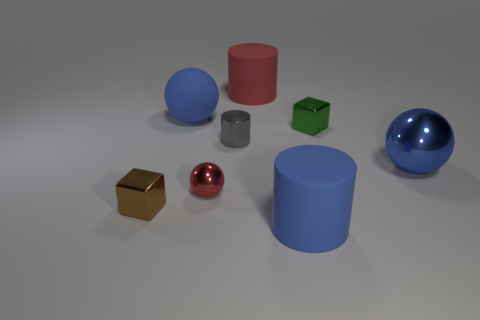What number of objects are big rubber cylinders that are behind the red metal object or tiny red rubber spheres?
Make the answer very short. 1. How big is the red thing on the left side of the tiny gray object?
Your answer should be very brief. Small. Is the size of the red rubber thing the same as the blue matte object that is in front of the brown thing?
Ensure brevity in your answer.  Yes. There is a large matte cylinder that is in front of the shiny sphere right of the small metal cylinder; what color is it?
Provide a short and direct response. Blue. How many other objects are there of the same color as the tiny cylinder?
Make the answer very short. 0. What is the size of the blue metallic sphere?
Offer a terse response. Large. Is the number of small green metallic things behind the green metallic block greater than the number of big blue metal objects that are behind the small gray thing?
Your response must be concise. No. How many large shiny things are in front of the metal block that is to the left of the small gray shiny cylinder?
Keep it short and to the point. 0. There is a big red thing that is behind the gray object; does it have the same shape as the brown metal object?
Your answer should be very brief. No. What is the material of the red thing that is the same shape as the gray metal object?
Provide a short and direct response. Rubber. 